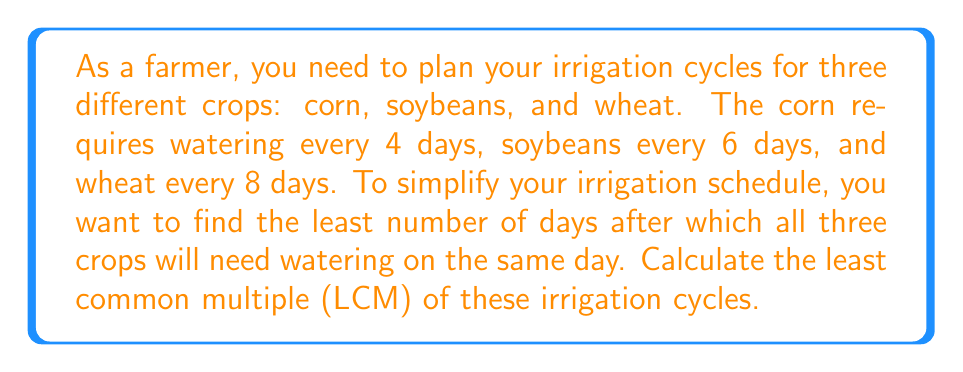Could you help me with this problem? To solve this problem, we need to find the least common multiple (LCM) of 4, 6, and 8. Let's approach this step-by-step:

1) First, let's find the prime factorization of each number:
   
   $4 = 2^2$
   $6 = 2 \times 3$
   $8 = 2^3$

2) The LCM will include the highest power of each prime factor from these numbers. So we need:
   
   $2^3$ (the highest power of 2, which comes from 8)
   $3^1$ (from 6)

3) Therefore, the LCM is:

   $LCM = 2^3 \times 3 = 8 \times 3 = 24$

We can verify this result:
- 24 is divisible by 4 (24 ÷ 4 = 6)
- 24 is divisible by 6 (24 ÷ 6 = 4)
- 24 is divisible by 8 (24 ÷ 8 = 3)

This means that after 24 days, all three crops will need watering on the same day, and this is the smallest number of days for which this is true.
Answer: The least common multiple of the irrigation cycles is 24 days. 